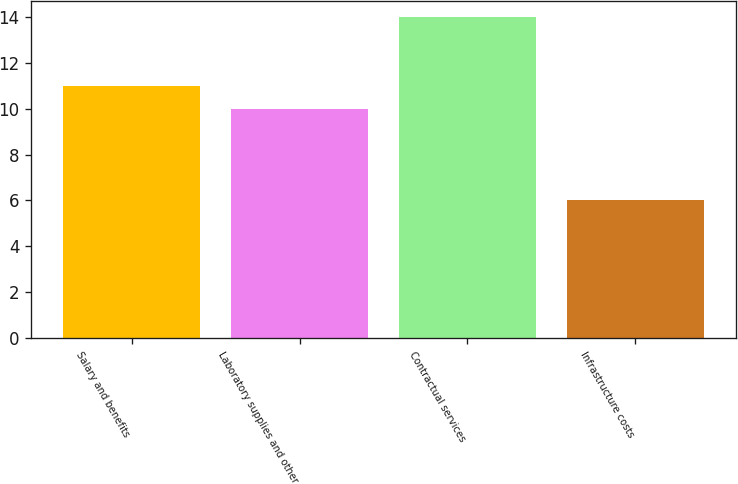Convert chart to OTSL. <chart><loc_0><loc_0><loc_500><loc_500><bar_chart><fcel>Salary and benefits<fcel>Laboratory supplies and other<fcel>Contractual services<fcel>Infrastructure costs<nl><fcel>11<fcel>10<fcel>14<fcel>6<nl></chart> 